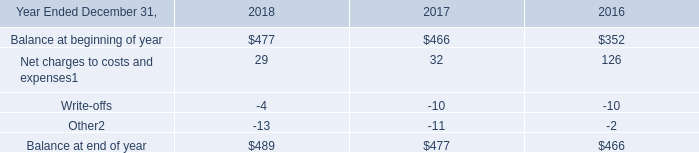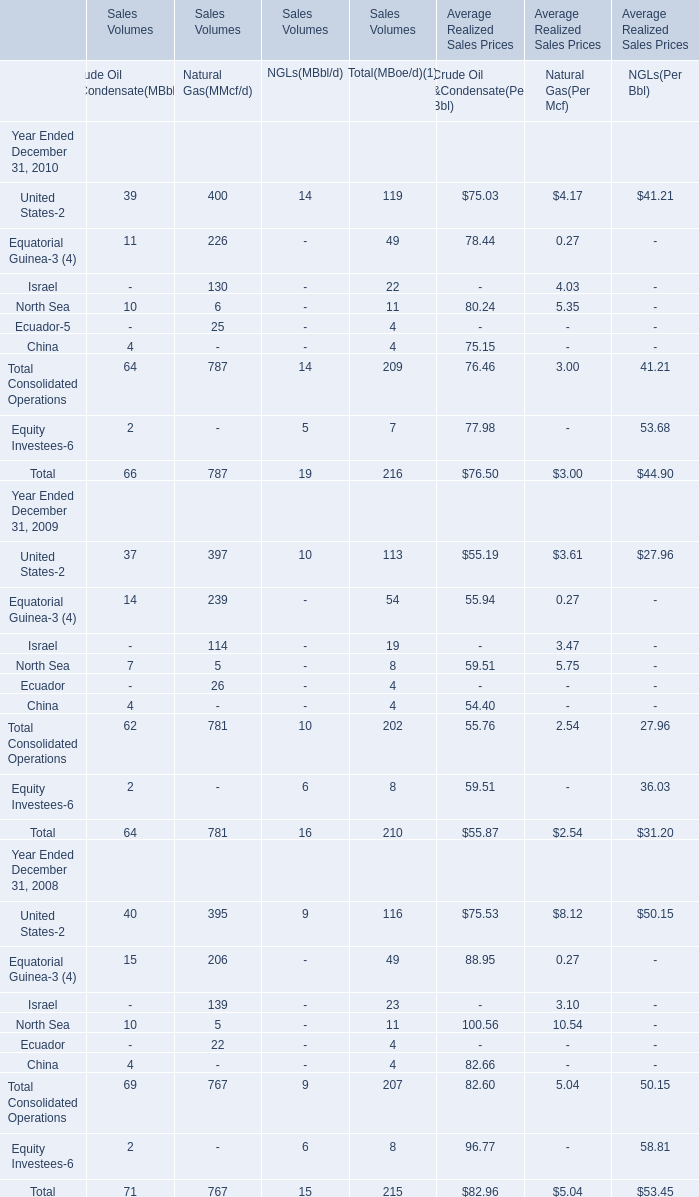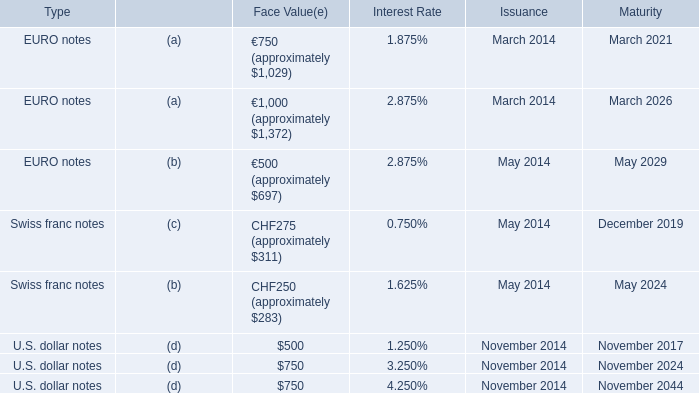What do all NGLs(MBbl/d) sum up, excluding those negative ones in 2009? 
Computations: (10 + 6)
Answer: 16.0. 